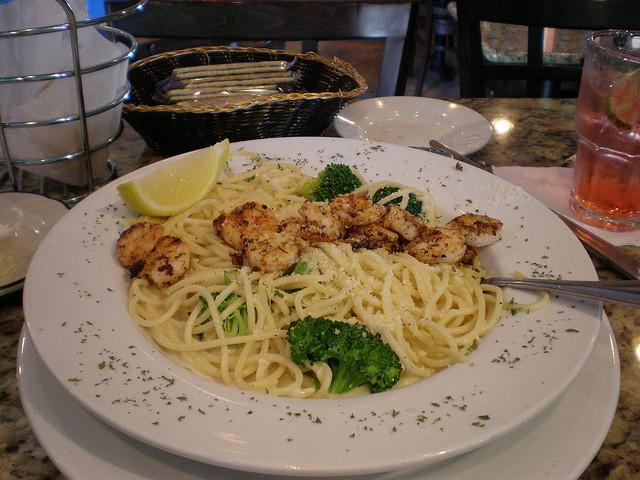What is in the spaghetti?

Choices:
A) meatball
B) shrimp
C) tomato sauce
D) egg shrimp 